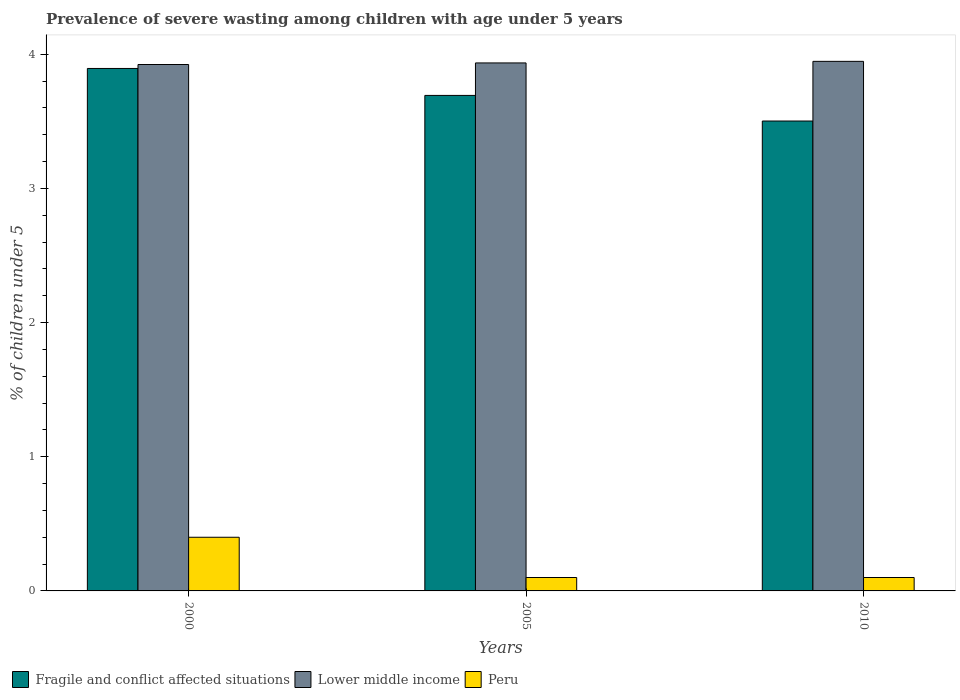How many different coloured bars are there?
Offer a very short reply. 3. How many groups of bars are there?
Offer a very short reply. 3. How many bars are there on the 2nd tick from the right?
Provide a short and direct response. 3. What is the label of the 3rd group of bars from the left?
Ensure brevity in your answer.  2010. In how many cases, is the number of bars for a given year not equal to the number of legend labels?
Ensure brevity in your answer.  0. What is the percentage of severely wasted children in Lower middle income in 2000?
Offer a very short reply. 3.92. Across all years, what is the maximum percentage of severely wasted children in Fragile and conflict affected situations?
Ensure brevity in your answer.  3.89. Across all years, what is the minimum percentage of severely wasted children in Lower middle income?
Ensure brevity in your answer.  3.92. What is the total percentage of severely wasted children in Peru in the graph?
Offer a very short reply. 0.6. What is the difference between the percentage of severely wasted children in Peru in 2005 and that in 2010?
Ensure brevity in your answer.  0. What is the difference between the percentage of severely wasted children in Lower middle income in 2000 and the percentage of severely wasted children in Peru in 2005?
Make the answer very short. 3.82. What is the average percentage of severely wasted children in Lower middle income per year?
Offer a very short reply. 3.94. In the year 2010, what is the difference between the percentage of severely wasted children in Fragile and conflict affected situations and percentage of severely wasted children in Lower middle income?
Provide a short and direct response. -0.44. What is the ratio of the percentage of severely wasted children in Fragile and conflict affected situations in 2000 to that in 2010?
Provide a succinct answer. 1.11. What is the difference between the highest and the second highest percentage of severely wasted children in Peru?
Your answer should be compact. 0.3. What is the difference between the highest and the lowest percentage of severely wasted children in Lower middle income?
Your answer should be very brief. 0.02. In how many years, is the percentage of severely wasted children in Peru greater than the average percentage of severely wasted children in Peru taken over all years?
Your response must be concise. 1. What does the 2nd bar from the left in 2000 represents?
Your response must be concise. Lower middle income. What does the 2nd bar from the right in 2000 represents?
Provide a short and direct response. Lower middle income. How many bars are there?
Your response must be concise. 9. Are all the bars in the graph horizontal?
Provide a succinct answer. No. What is the difference between two consecutive major ticks on the Y-axis?
Give a very brief answer. 1. Are the values on the major ticks of Y-axis written in scientific E-notation?
Ensure brevity in your answer.  No. Does the graph contain any zero values?
Offer a very short reply. No. Does the graph contain grids?
Your answer should be compact. No. Where does the legend appear in the graph?
Your answer should be very brief. Bottom left. What is the title of the graph?
Your answer should be very brief. Prevalence of severe wasting among children with age under 5 years. What is the label or title of the Y-axis?
Make the answer very short. % of children under 5. What is the % of children under 5 in Fragile and conflict affected situations in 2000?
Offer a very short reply. 3.89. What is the % of children under 5 in Lower middle income in 2000?
Offer a very short reply. 3.92. What is the % of children under 5 of Peru in 2000?
Offer a terse response. 0.4. What is the % of children under 5 in Fragile and conflict affected situations in 2005?
Make the answer very short. 3.69. What is the % of children under 5 of Lower middle income in 2005?
Ensure brevity in your answer.  3.94. What is the % of children under 5 of Peru in 2005?
Provide a short and direct response. 0.1. What is the % of children under 5 in Fragile and conflict affected situations in 2010?
Offer a very short reply. 3.5. What is the % of children under 5 of Lower middle income in 2010?
Provide a succinct answer. 3.95. What is the % of children under 5 of Peru in 2010?
Keep it short and to the point. 0.1. Across all years, what is the maximum % of children under 5 of Fragile and conflict affected situations?
Give a very brief answer. 3.89. Across all years, what is the maximum % of children under 5 in Lower middle income?
Ensure brevity in your answer.  3.95. Across all years, what is the maximum % of children under 5 of Peru?
Offer a very short reply. 0.4. Across all years, what is the minimum % of children under 5 in Fragile and conflict affected situations?
Keep it short and to the point. 3.5. Across all years, what is the minimum % of children under 5 in Lower middle income?
Provide a succinct answer. 3.92. Across all years, what is the minimum % of children under 5 of Peru?
Provide a short and direct response. 0.1. What is the total % of children under 5 of Fragile and conflict affected situations in the graph?
Make the answer very short. 11.09. What is the total % of children under 5 in Lower middle income in the graph?
Your response must be concise. 11.81. What is the total % of children under 5 of Peru in the graph?
Make the answer very short. 0.6. What is the difference between the % of children under 5 of Fragile and conflict affected situations in 2000 and that in 2005?
Make the answer very short. 0.2. What is the difference between the % of children under 5 in Lower middle income in 2000 and that in 2005?
Provide a short and direct response. -0.01. What is the difference between the % of children under 5 in Peru in 2000 and that in 2005?
Provide a succinct answer. 0.3. What is the difference between the % of children under 5 in Fragile and conflict affected situations in 2000 and that in 2010?
Ensure brevity in your answer.  0.39. What is the difference between the % of children under 5 of Lower middle income in 2000 and that in 2010?
Offer a terse response. -0.02. What is the difference between the % of children under 5 of Peru in 2000 and that in 2010?
Your answer should be compact. 0.3. What is the difference between the % of children under 5 of Fragile and conflict affected situations in 2005 and that in 2010?
Your answer should be very brief. 0.19. What is the difference between the % of children under 5 in Lower middle income in 2005 and that in 2010?
Provide a short and direct response. -0.01. What is the difference between the % of children under 5 of Peru in 2005 and that in 2010?
Your response must be concise. 0. What is the difference between the % of children under 5 in Fragile and conflict affected situations in 2000 and the % of children under 5 in Lower middle income in 2005?
Make the answer very short. -0.04. What is the difference between the % of children under 5 of Fragile and conflict affected situations in 2000 and the % of children under 5 of Peru in 2005?
Give a very brief answer. 3.79. What is the difference between the % of children under 5 of Lower middle income in 2000 and the % of children under 5 of Peru in 2005?
Offer a terse response. 3.82. What is the difference between the % of children under 5 in Fragile and conflict affected situations in 2000 and the % of children under 5 in Lower middle income in 2010?
Offer a very short reply. -0.05. What is the difference between the % of children under 5 of Fragile and conflict affected situations in 2000 and the % of children under 5 of Peru in 2010?
Ensure brevity in your answer.  3.79. What is the difference between the % of children under 5 in Lower middle income in 2000 and the % of children under 5 in Peru in 2010?
Your answer should be very brief. 3.82. What is the difference between the % of children under 5 in Fragile and conflict affected situations in 2005 and the % of children under 5 in Lower middle income in 2010?
Make the answer very short. -0.25. What is the difference between the % of children under 5 of Fragile and conflict affected situations in 2005 and the % of children under 5 of Peru in 2010?
Provide a succinct answer. 3.59. What is the difference between the % of children under 5 in Lower middle income in 2005 and the % of children under 5 in Peru in 2010?
Your response must be concise. 3.84. What is the average % of children under 5 in Fragile and conflict affected situations per year?
Make the answer very short. 3.7. What is the average % of children under 5 in Lower middle income per year?
Make the answer very short. 3.94. In the year 2000, what is the difference between the % of children under 5 of Fragile and conflict affected situations and % of children under 5 of Lower middle income?
Offer a terse response. -0.03. In the year 2000, what is the difference between the % of children under 5 of Fragile and conflict affected situations and % of children under 5 of Peru?
Ensure brevity in your answer.  3.49. In the year 2000, what is the difference between the % of children under 5 of Lower middle income and % of children under 5 of Peru?
Make the answer very short. 3.52. In the year 2005, what is the difference between the % of children under 5 of Fragile and conflict affected situations and % of children under 5 of Lower middle income?
Make the answer very short. -0.24. In the year 2005, what is the difference between the % of children under 5 of Fragile and conflict affected situations and % of children under 5 of Peru?
Ensure brevity in your answer.  3.59. In the year 2005, what is the difference between the % of children under 5 of Lower middle income and % of children under 5 of Peru?
Your answer should be very brief. 3.84. In the year 2010, what is the difference between the % of children under 5 in Fragile and conflict affected situations and % of children under 5 in Lower middle income?
Your answer should be compact. -0.44. In the year 2010, what is the difference between the % of children under 5 in Fragile and conflict affected situations and % of children under 5 in Peru?
Give a very brief answer. 3.4. In the year 2010, what is the difference between the % of children under 5 in Lower middle income and % of children under 5 in Peru?
Provide a short and direct response. 3.85. What is the ratio of the % of children under 5 in Fragile and conflict affected situations in 2000 to that in 2005?
Provide a succinct answer. 1.05. What is the ratio of the % of children under 5 of Lower middle income in 2000 to that in 2005?
Offer a very short reply. 1. What is the ratio of the % of children under 5 in Fragile and conflict affected situations in 2000 to that in 2010?
Give a very brief answer. 1.11. What is the ratio of the % of children under 5 in Lower middle income in 2000 to that in 2010?
Give a very brief answer. 0.99. What is the ratio of the % of children under 5 of Peru in 2000 to that in 2010?
Your answer should be very brief. 4. What is the ratio of the % of children under 5 of Fragile and conflict affected situations in 2005 to that in 2010?
Make the answer very short. 1.05. What is the ratio of the % of children under 5 in Lower middle income in 2005 to that in 2010?
Keep it short and to the point. 1. What is the ratio of the % of children under 5 of Peru in 2005 to that in 2010?
Give a very brief answer. 1. What is the difference between the highest and the second highest % of children under 5 of Fragile and conflict affected situations?
Give a very brief answer. 0.2. What is the difference between the highest and the second highest % of children under 5 in Lower middle income?
Offer a terse response. 0.01. What is the difference between the highest and the lowest % of children under 5 of Fragile and conflict affected situations?
Keep it short and to the point. 0.39. What is the difference between the highest and the lowest % of children under 5 in Lower middle income?
Your answer should be very brief. 0.02. What is the difference between the highest and the lowest % of children under 5 of Peru?
Offer a very short reply. 0.3. 